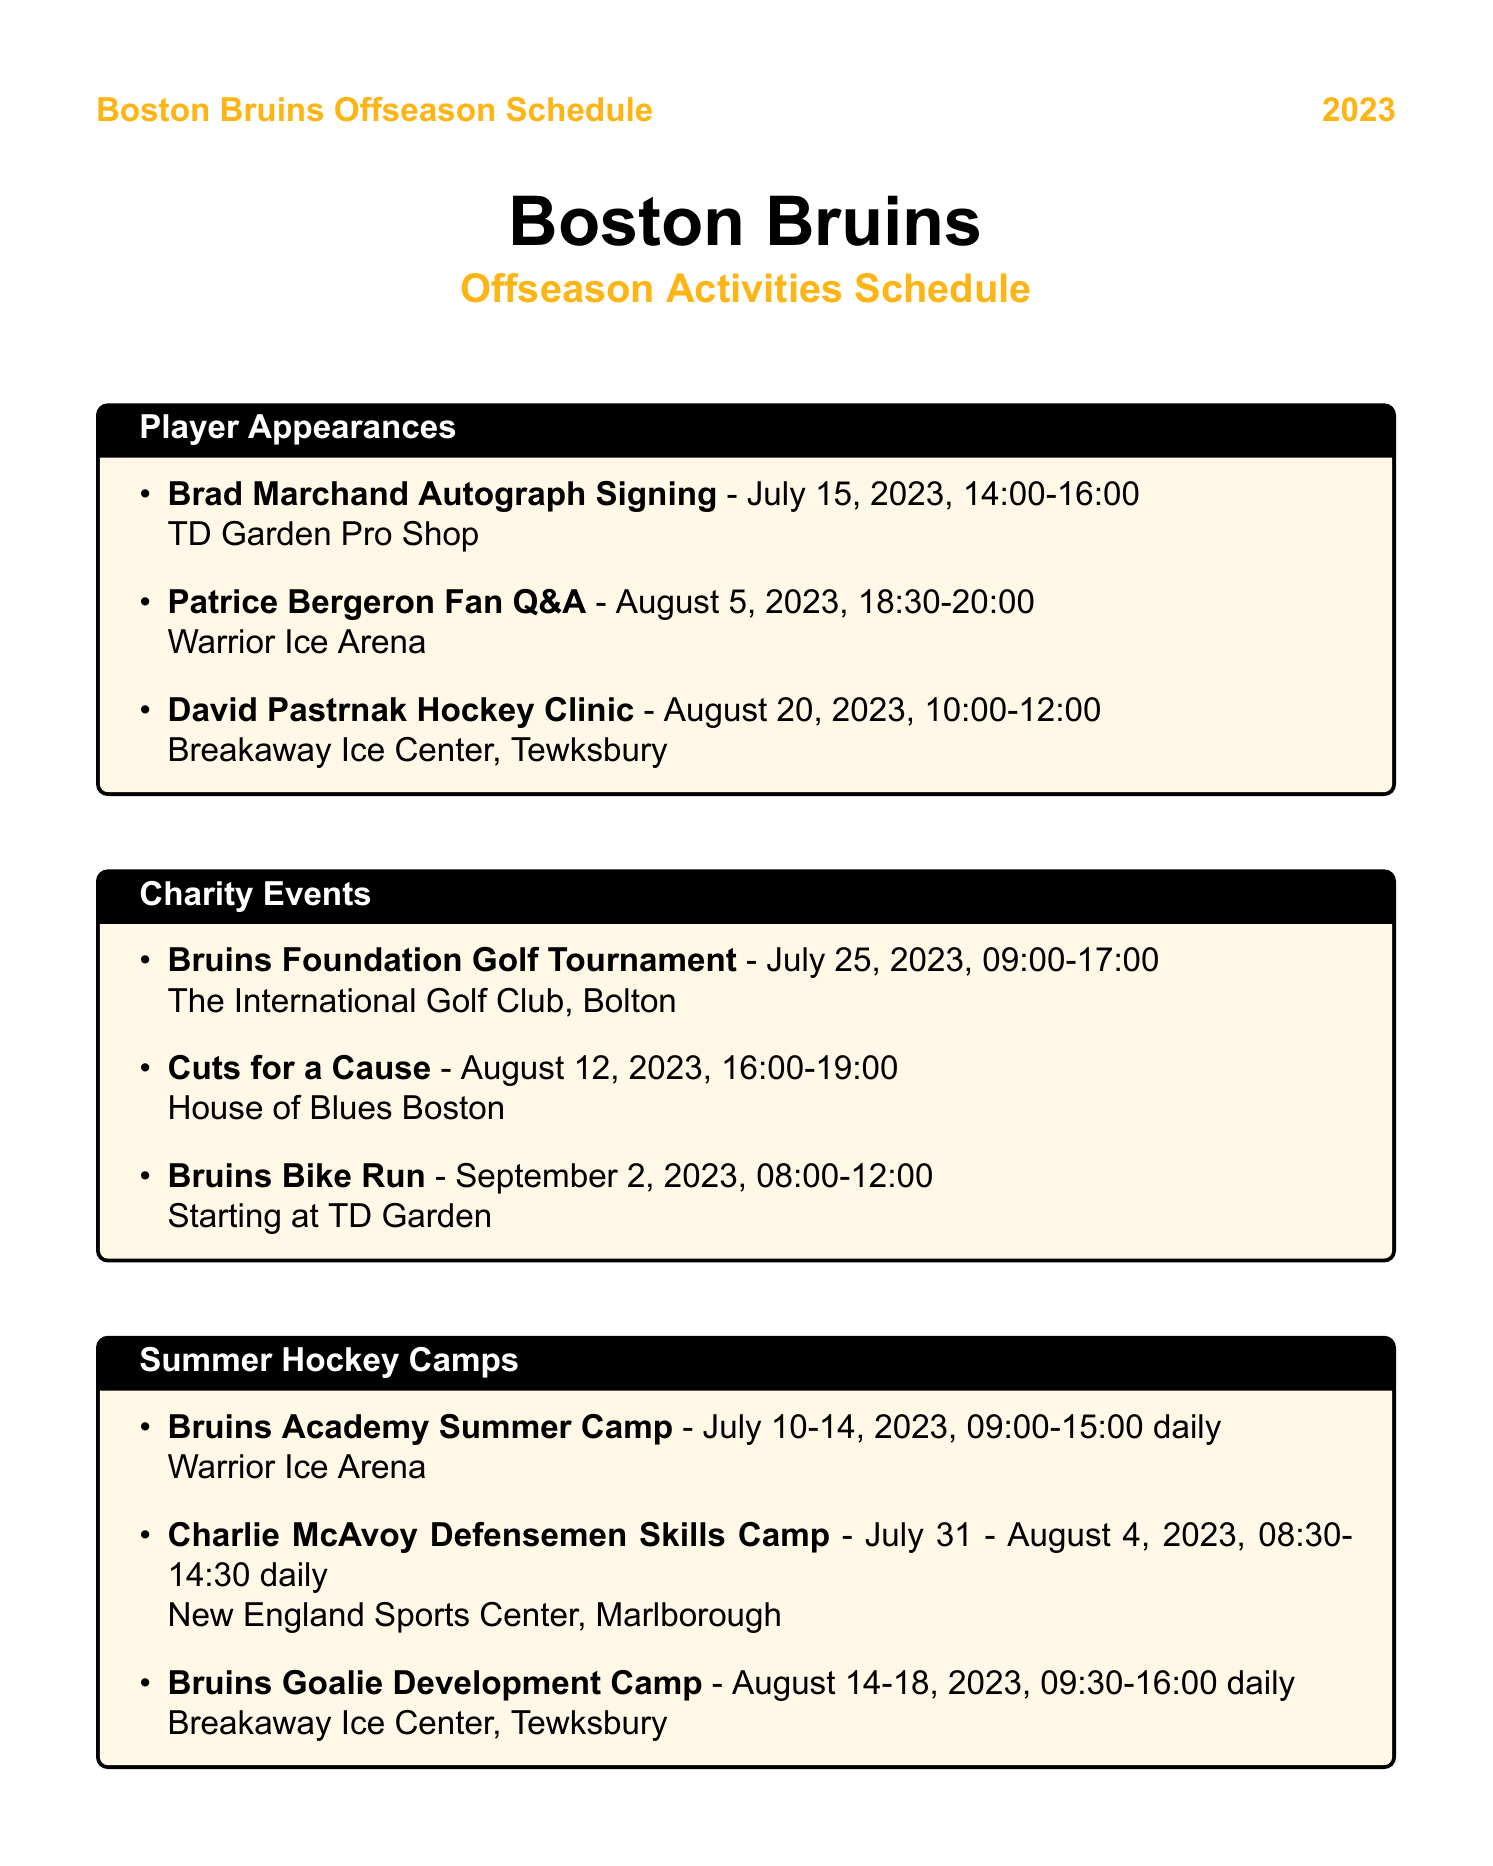What date is the Bruins Foundation Golf Tournament? The document lists the date for the Bruins Foundation Golf Tournament as July 25, 2023.
Answer: July 25, 2023 Who is hosting a fan Q&A session? According to the document, the fan Q&A session will be hosted by Bruins captain Patrice Bergeron.
Answer: Patrice Bergeron What is the location of the Bruins Bike Run? The document states that the Bruins Bike Run starts at TD Garden.
Answer: Starting at TD Garden How many days does the Bruins Academy Summer Camp last? The document shows that the Bruins Academy Summer Camp runs from July 10 to July 14, which is 5 days.
Answer: 5 days What time does the Black & Gold Scrimmage start? The schedule indicates that the Black & Gold Scrimmage begins at 19:00.
Answer: 19:00 Which player is conducting a hockey clinic on August 20? The document specifies that David Pastrnak is conducting the hockey clinic on that date.
Answer: David Pastrnak What type of event is Cuts for a Cause? The document describes Cuts for a Cause as an event where players shave their heads to raise money for pediatric cancer research.
Answer: Shaving heads for charity When does the Charlie McAvoy Defensemen Skills Camp start? The schedule notes that the Charlie McAvoy Defensemen Skills Camp starts on July 31, 2023.
Answer: July 31, 2023 